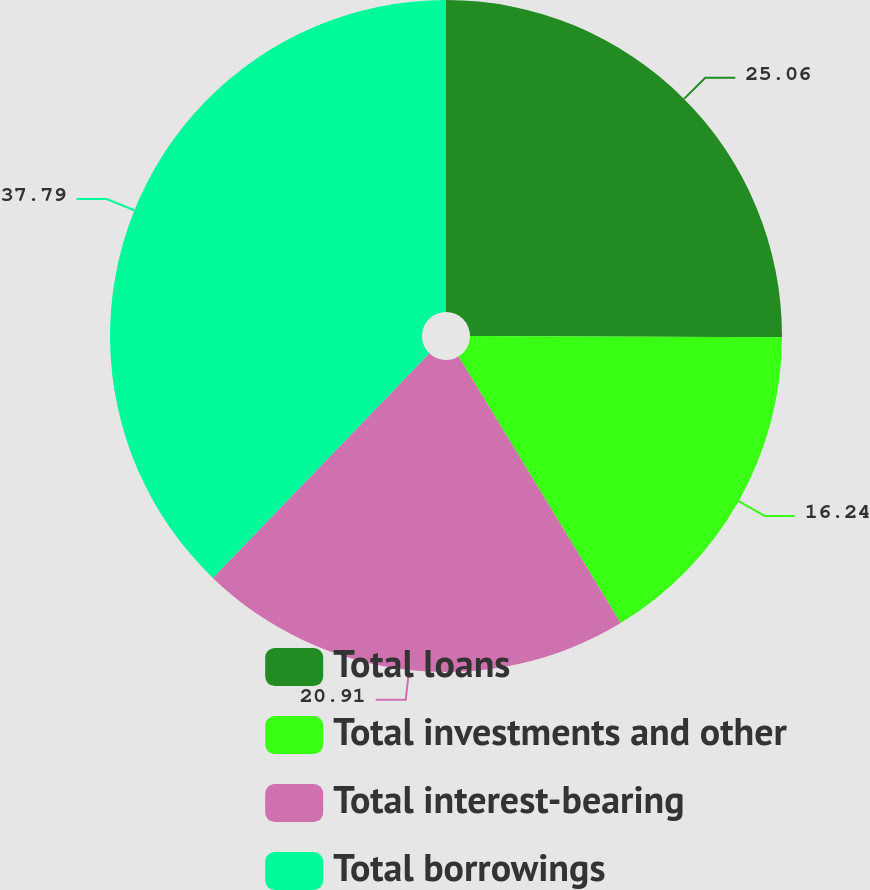Convert chart. <chart><loc_0><loc_0><loc_500><loc_500><pie_chart><fcel>Total loans<fcel>Total investments and other<fcel>Total interest-bearing<fcel>Total borrowings<nl><fcel>25.06%<fcel>16.24%<fcel>20.91%<fcel>37.79%<nl></chart> 